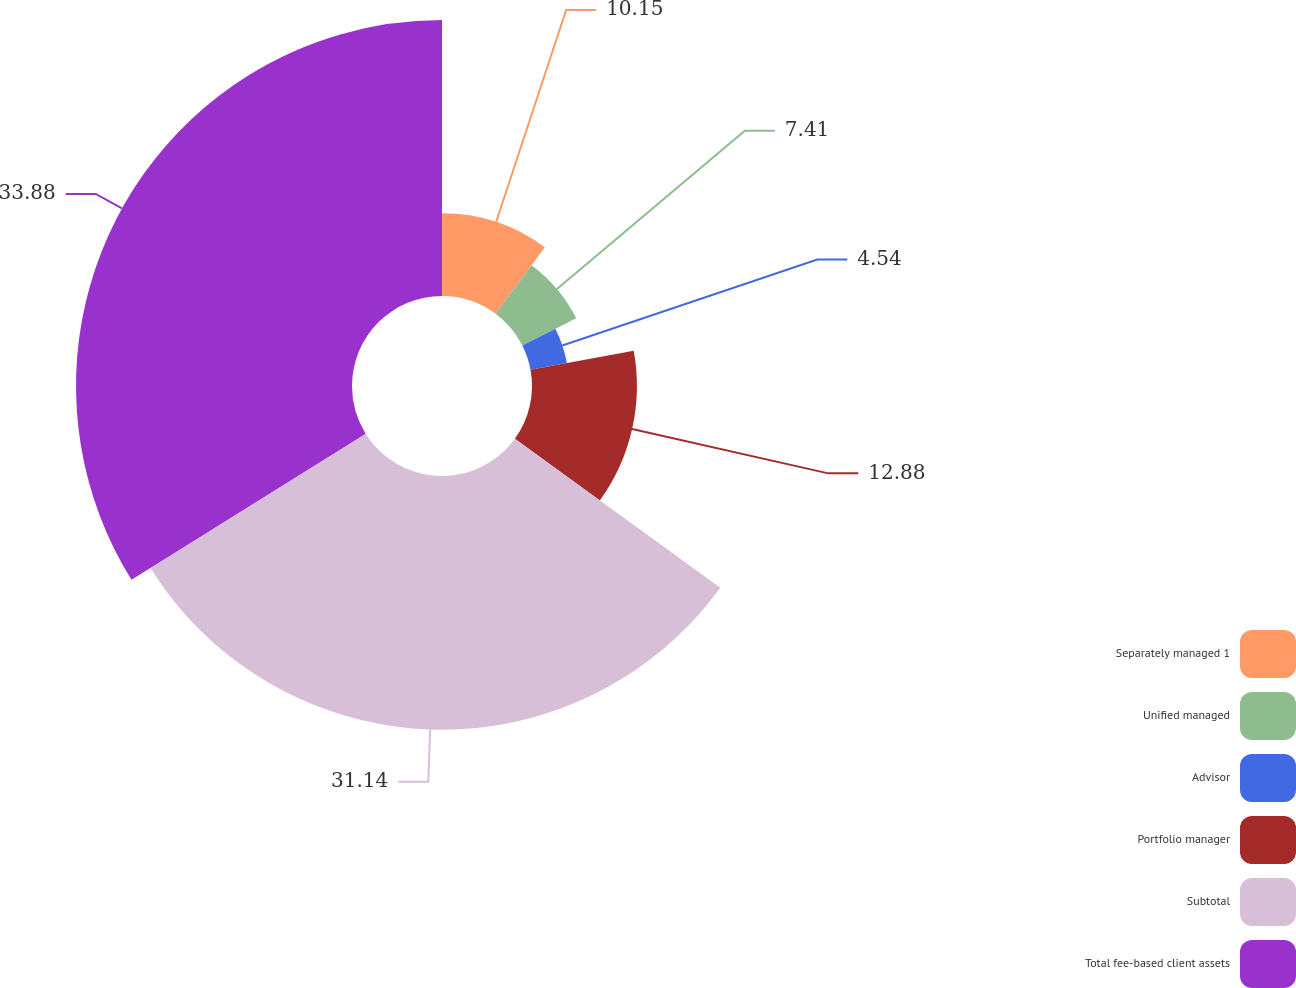Convert chart to OTSL. <chart><loc_0><loc_0><loc_500><loc_500><pie_chart><fcel>Separately managed 1<fcel>Unified managed<fcel>Advisor<fcel>Portfolio manager<fcel>Subtotal<fcel>Total fee-based client assets<nl><fcel>10.15%<fcel>7.41%<fcel>4.54%<fcel>12.88%<fcel>31.14%<fcel>33.88%<nl></chart> 